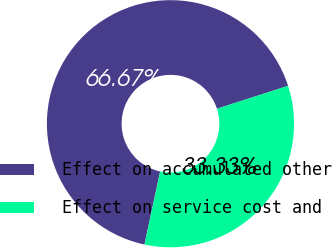Convert chart. <chart><loc_0><loc_0><loc_500><loc_500><pie_chart><fcel>Effect on accumulated other<fcel>Effect on service cost and<nl><fcel>66.67%<fcel>33.33%<nl></chart> 